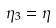<formula> <loc_0><loc_0><loc_500><loc_500>\eta _ { 3 } = \eta</formula> 